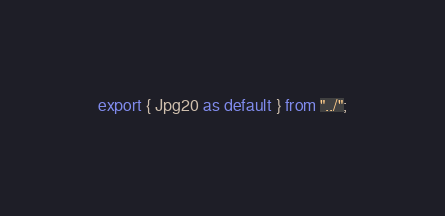Convert code to text. <code><loc_0><loc_0><loc_500><loc_500><_TypeScript_>export { Jpg20 as default } from "../";
</code> 